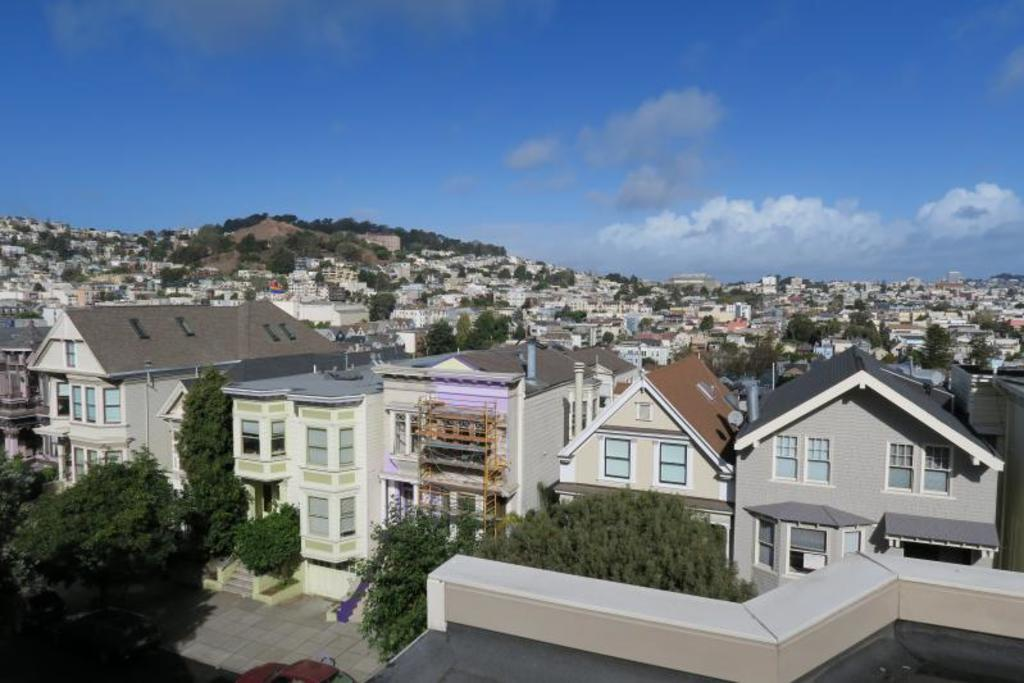What type of structures can be seen in the image? There are buildings in the image. What is present between the buildings? There are trees between the buildings. What can be seen in the sky in the image? There are clouds visible in the sky. What is the reason for the argument between the clouds in the image? There is no argument between the clouds in the image, as clouds do not engage in arguments. 